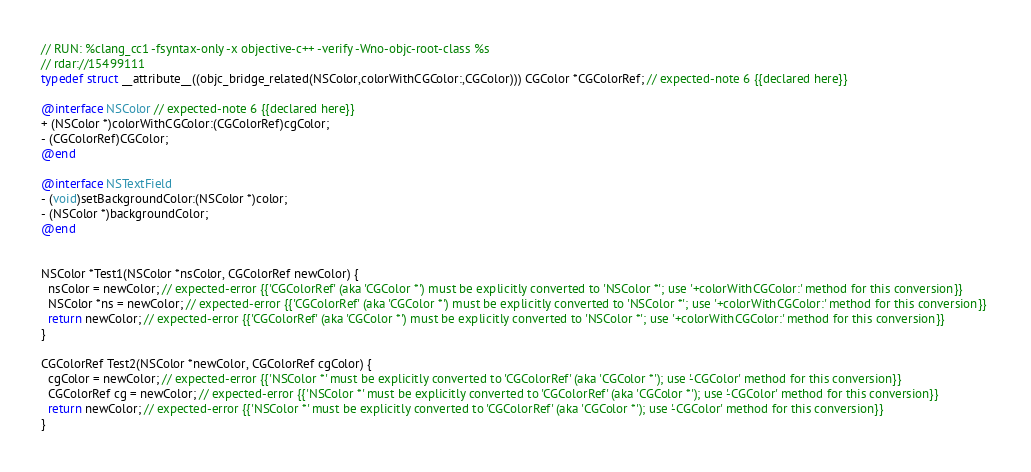Convert code to text. <code><loc_0><loc_0><loc_500><loc_500><_ObjectiveC_>// RUN: %clang_cc1 -fsyntax-only -x objective-c++ -verify -Wno-objc-root-class %s
// rdar://15499111
typedef struct __attribute__((objc_bridge_related(NSColor,colorWithCGColor:,CGColor))) CGColor *CGColorRef; // expected-note 6 {{declared here}}

@interface NSColor // expected-note 6 {{declared here}}
+ (NSColor *)colorWithCGColor:(CGColorRef)cgColor;
- (CGColorRef)CGColor;
@end

@interface NSTextField
- (void)setBackgroundColor:(NSColor *)color;
- (NSColor *)backgroundColor;
@end


NSColor *Test1(NSColor *nsColor, CGColorRef newColor) {
  nsColor = newColor; // expected-error {{'CGColorRef' (aka 'CGColor *') must be explicitly converted to 'NSColor *'; use '+colorWithCGColor:' method for this conversion}}
  NSColor *ns = newColor; // expected-error {{'CGColorRef' (aka 'CGColor *') must be explicitly converted to 'NSColor *'; use '+colorWithCGColor:' method for this conversion}} 
  return newColor; // expected-error {{'CGColorRef' (aka 'CGColor *') must be explicitly converted to 'NSColor *'; use '+colorWithCGColor:' method for this conversion}} 
}

CGColorRef Test2(NSColor *newColor, CGColorRef cgColor) {
  cgColor = newColor; // expected-error {{'NSColor *' must be explicitly converted to 'CGColorRef' (aka 'CGColor *'); use '-CGColor' method for this conversion}}
  CGColorRef cg = newColor; // expected-error {{'NSColor *' must be explicitly converted to 'CGColorRef' (aka 'CGColor *'); use '-CGColor' method for this conversion}} 
  return newColor; // expected-error {{'NSColor *' must be explicitly converted to 'CGColorRef' (aka 'CGColor *'); use '-CGColor' method for this conversion}}
}

</code> 